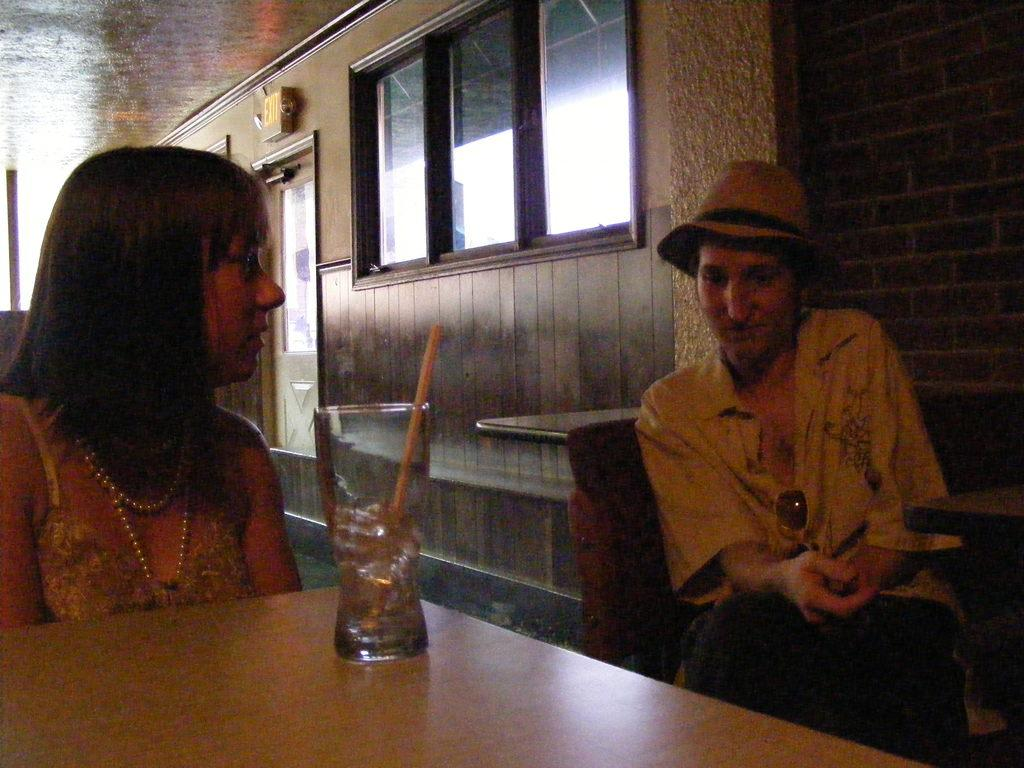How many people are in the image? There are two people in the image. What are the people doing in the image? The people are sitting on chairs. Can you describe any objects on a table in the image? There is a glass with a straw on a table. What type of fruit is the duck eating in the image? There is no duck or fruit present in the image. How many teeth can be seen in the mouth of the person in the image? The image does not show the inside of anyone's mouth, so it is not possible to determine the number of teeth visible. 